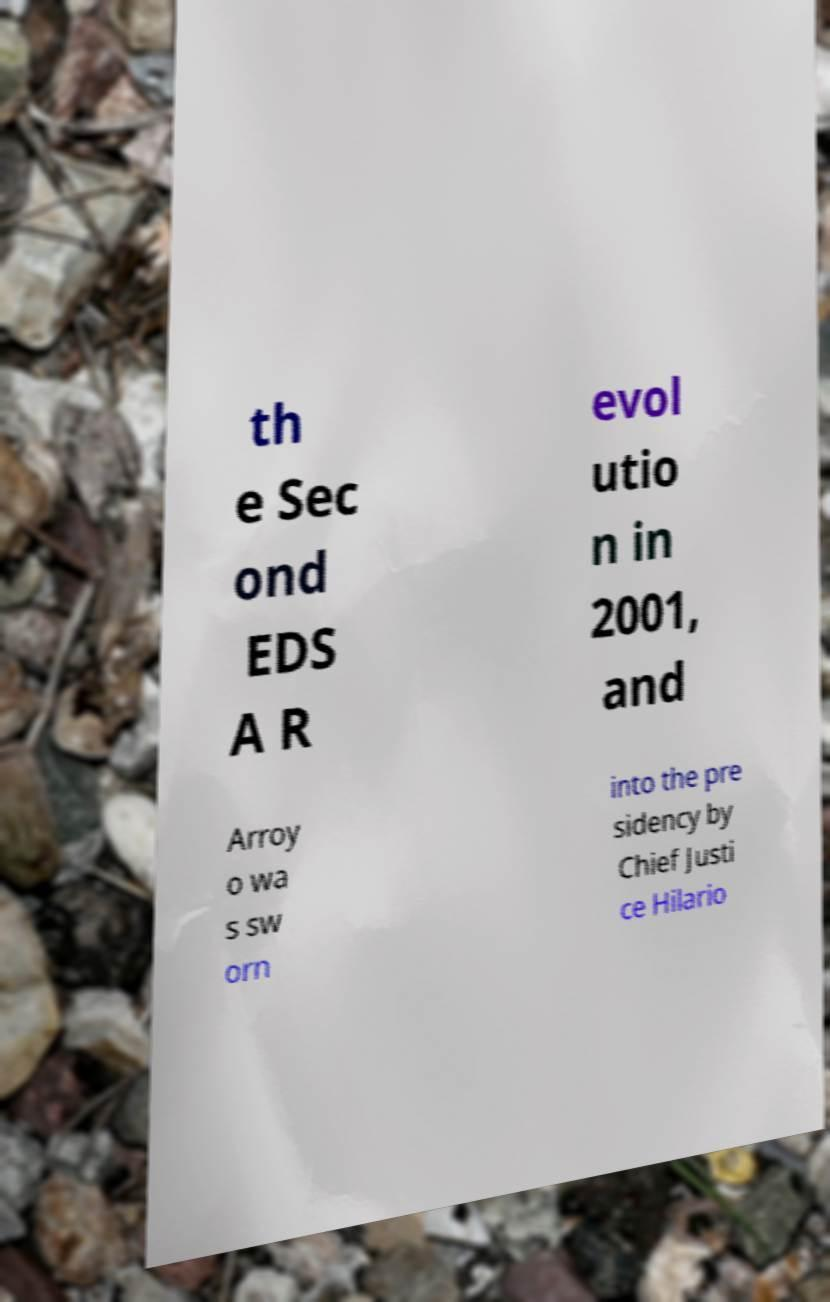There's text embedded in this image that I need extracted. Can you transcribe it verbatim? th e Sec ond EDS A R evol utio n in 2001, and Arroy o wa s sw orn into the pre sidency by Chief Justi ce Hilario 